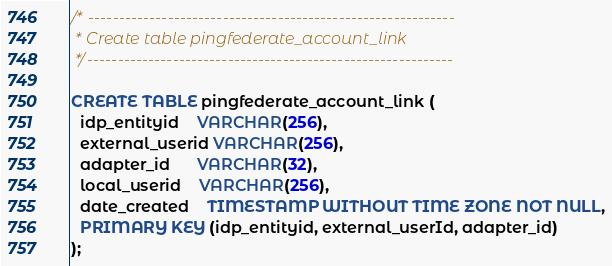<code> <loc_0><loc_0><loc_500><loc_500><_SQL_>/* ------------------------------------------------------------
 * Create table pingfederate_account_link
 */------------------------------------------------------------

CREATE TABLE pingfederate_account_link (
  idp_entityid    VARCHAR(256),
  external_userid VARCHAR(256),
  adapter_id      VARCHAR(32),
  local_userid    VARCHAR(256),
  date_created    TIMESTAMP WITHOUT TIME ZONE NOT NULL,
  PRIMARY KEY (idp_entityid, external_userId, adapter_id)
);
</code> 